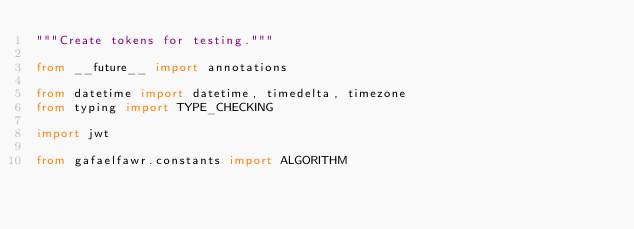<code> <loc_0><loc_0><loc_500><loc_500><_Python_>"""Create tokens for testing."""

from __future__ import annotations

from datetime import datetime, timedelta, timezone
from typing import TYPE_CHECKING

import jwt

from gafaelfawr.constants import ALGORITHM</code> 